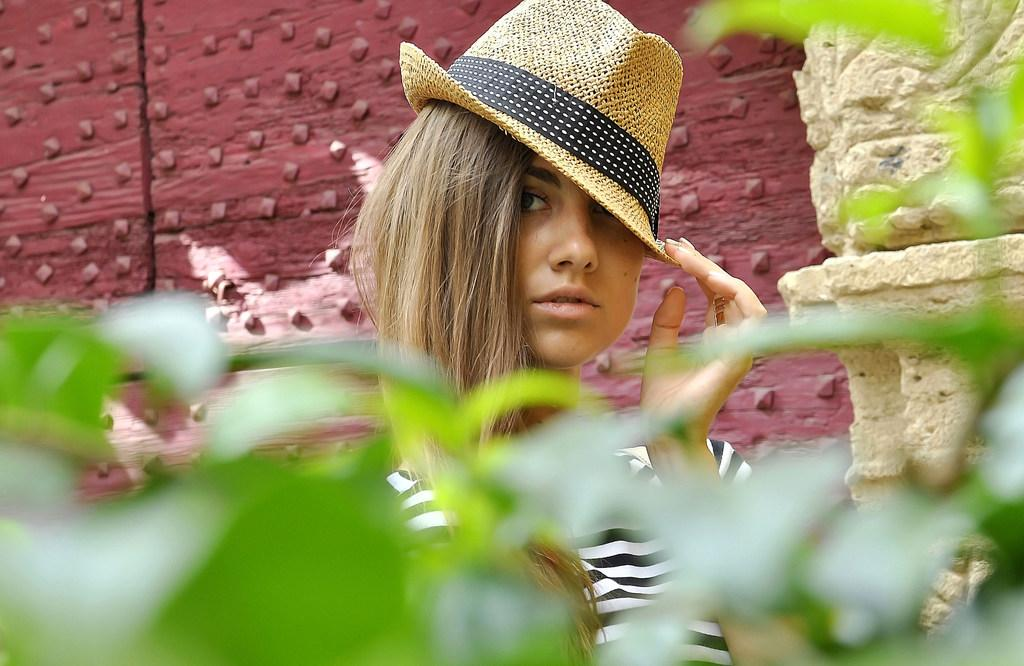Who is the main subject in the image? There is a woman in the image. What is the woman wearing on her head? The woman is wearing a hat. What type of clothing is the woman wearing on her upper body? The woman is wearing a T-shirt. What can be seen behind the woman in the image? There is a wall visible behind the woman. What type of vegetation is present at the bottom of the image? Leaves are present at the bottom of the image. What type of train is visible in the image? There is no train present in the image. Where is the nest located in the image? There is no nest present in the image. 